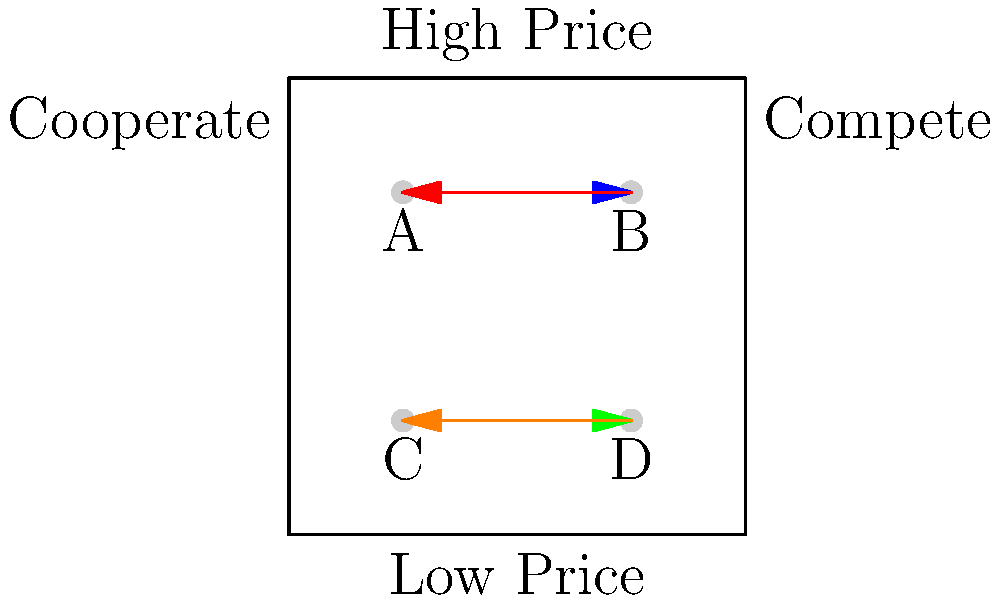In this digital marketplace scenario, four players (A, B, C, and D) represent competing platforms. Each player can choose to either cooperate (move left) or compete (move right) while simultaneously deciding on a high or low pricing strategy. Given the current state shown in the diagram, which player(s) are at their Nash equilibrium position, and why? To determine the Nash equilibrium, we need to analyze each player's strategy:

1. Define Nash equilibrium: A state where no player can unilaterally change their strategy to improve their outcome.

2. Analyze each player's position:
   - Player A: Currently cooperating with high price
   - Player B: Currently competing with high price
   - Player C: Currently cooperating with low price
   - Player D: Currently competing with low price

3. Consider potential moves:
   - A could move right (compete) or down (lower price)
   - B could move left (cooperate) or down (lower price)
   - C could move right (compete) or up (raise price)
   - D could move left (cooperate) or up (raise price)

4. Evaluate Nash equilibrium conditions:
   - A and B: In a prisoner's dilemma-like scenario. B is likely better off competing, so A is not at equilibrium.
   - C and D: Also in a prisoner's dilemma-like scenario. D is likely better off competing, so C is not at equilibrium.
   - A and C: Different pricing strategies suggest they're targeting different market segments, potentially at equilibrium.
   - B and D: Different pricing strategies, also potentially at equilibrium.

5. Conclusion:
   Players B and D are at their Nash equilibrium positions. They are both competing and have chosen different price points, suggesting they've found optimal strategies given the other players' choices. Neither can unilaterally improve their position by changing their strategy.
Answer: Players B and D 